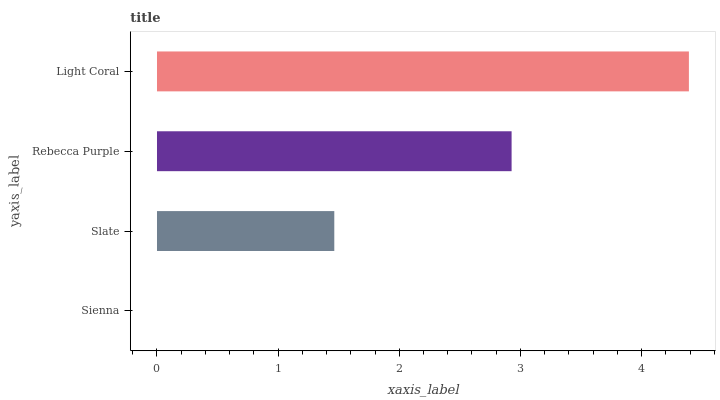Is Sienna the minimum?
Answer yes or no. Yes. Is Light Coral the maximum?
Answer yes or no. Yes. Is Slate the minimum?
Answer yes or no. No. Is Slate the maximum?
Answer yes or no. No. Is Slate greater than Sienna?
Answer yes or no. Yes. Is Sienna less than Slate?
Answer yes or no. Yes. Is Sienna greater than Slate?
Answer yes or no. No. Is Slate less than Sienna?
Answer yes or no. No. Is Rebecca Purple the high median?
Answer yes or no. Yes. Is Slate the low median?
Answer yes or no. Yes. Is Slate the high median?
Answer yes or no. No. Is Sienna the low median?
Answer yes or no. No. 